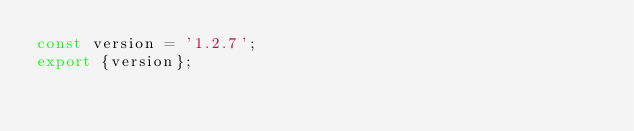Convert code to text. <code><loc_0><loc_0><loc_500><loc_500><_TypeScript_>const version = '1.2.7';
export {version};
</code> 